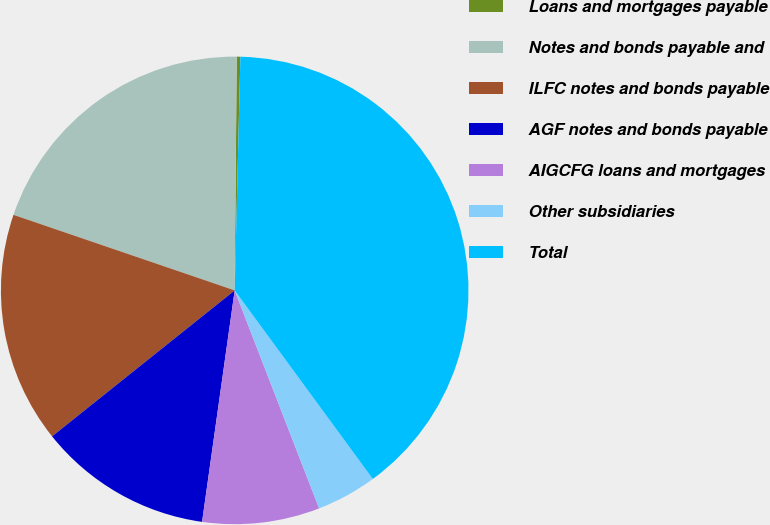Convert chart to OTSL. <chart><loc_0><loc_0><loc_500><loc_500><pie_chart><fcel>Loans and mortgages payable<fcel>Notes and bonds payable and<fcel>ILFC notes and bonds payable<fcel>AGF notes and bonds payable<fcel>AIGCFG loans and mortgages<fcel>Other subsidiaries<fcel>Total<nl><fcel>0.25%<fcel>19.9%<fcel>15.97%<fcel>12.04%<fcel>8.11%<fcel>4.18%<fcel>39.55%<nl></chart> 